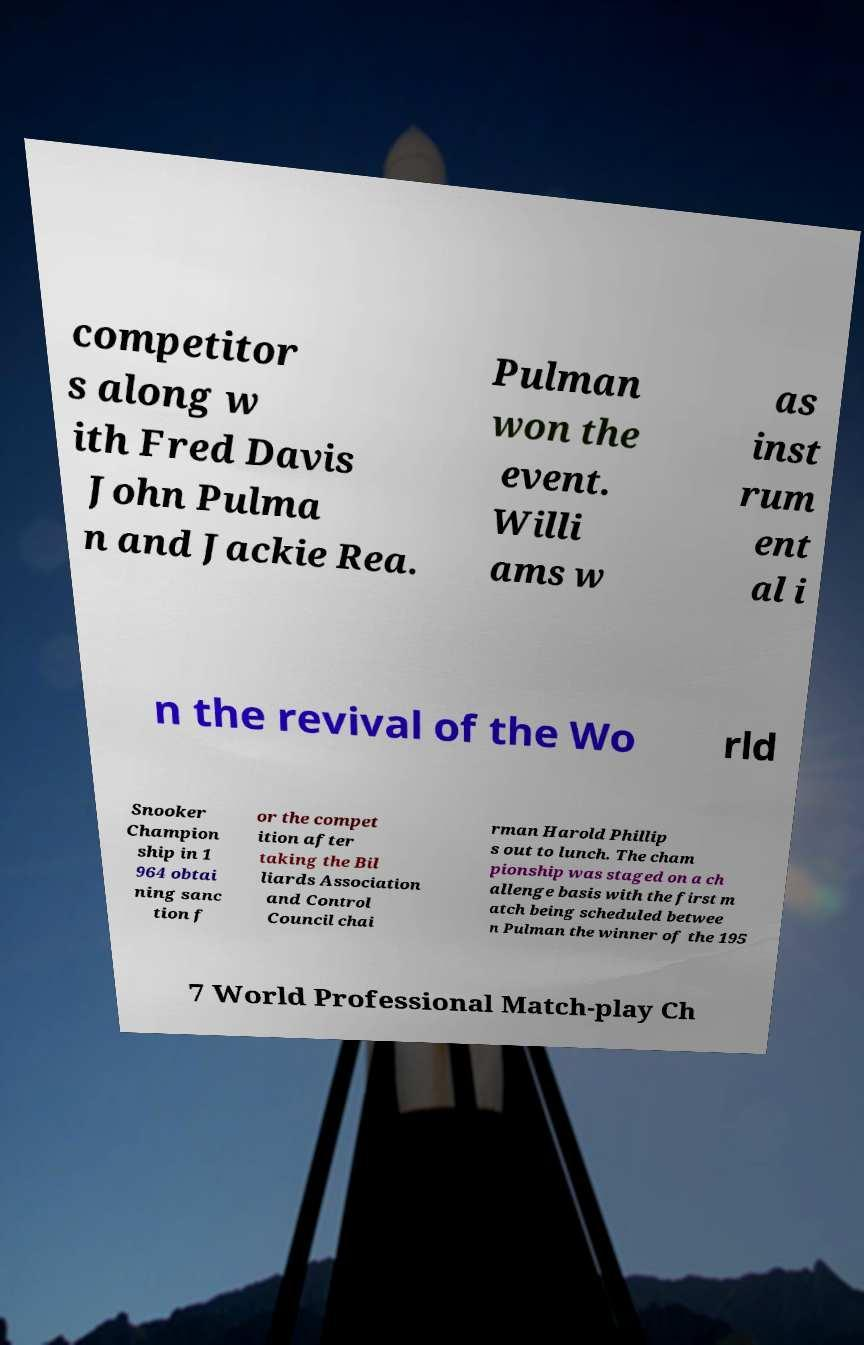There's text embedded in this image that I need extracted. Can you transcribe it verbatim? competitor s along w ith Fred Davis John Pulma n and Jackie Rea. Pulman won the event. Willi ams w as inst rum ent al i n the revival of the Wo rld Snooker Champion ship in 1 964 obtai ning sanc tion f or the compet ition after taking the Bil liards Association and Control Council chai rman Harold Phillip s out to lunch. The cham pionship was staged on a ch allenge basis with the first m atch being scheduled betwee n Pulman the winner of the 195 7 World Professional Match-play Ch 